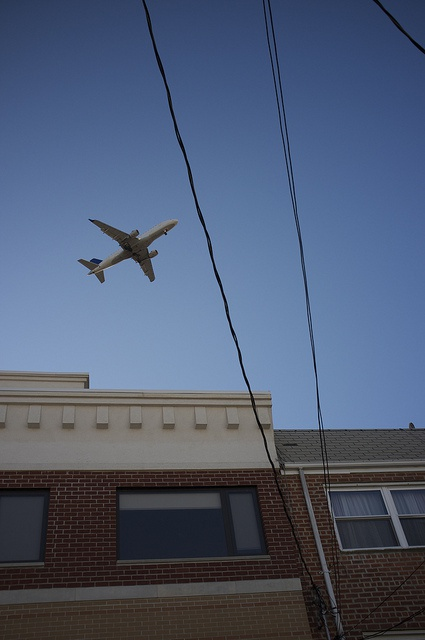Describe the objects in this image and their specific colors. I can see a airplane in navy, black, and gray tones in this image. 